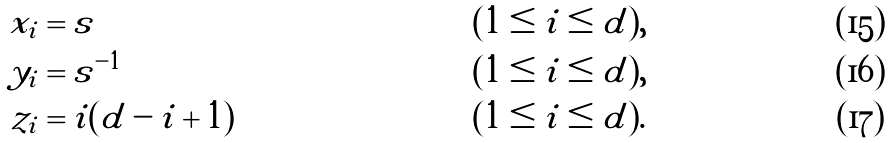Convert formula to latex. <formula><loc_0><loc_0><loc_500><loc_500>x _ { i } & = s & & ( 1 \leq i \leq d ) , \\ y _ { i } & = s ^ { - 1 } & & ( 1 \leq i \leq d ) , \\ z _ { i } & = i ( d - i + 1 ) & & ( 1 \leq i \leq d ) .</formula> 